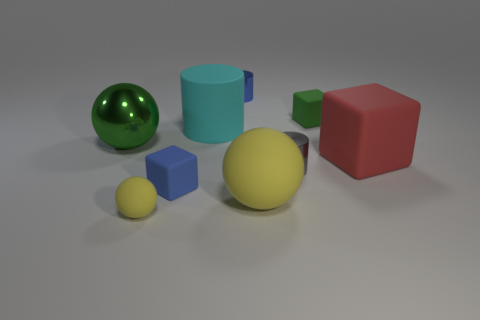Subtract all big spheres. How many spheres are left? 1 Subtract all yellow balls. How many balls are left? 1 Subtract all blocks. How many objects are left? 6 Add 1 big red shiny cylinders. How many objects exist? 10 Subtract 1 cylinders. How many cylinders are left? 2 Add 9 cyan rubber things. How many cyan rubber things are left? 10 Add 1 green blocks. How many green blocks exist? 2 Subtract 1 green blocks. How many objects are left? 8 Subtract all brown spheres. Subtract all red cubes. How many spheres are left? 3 Subtract all yellow cylinders. How many gray blocks are left? 0 